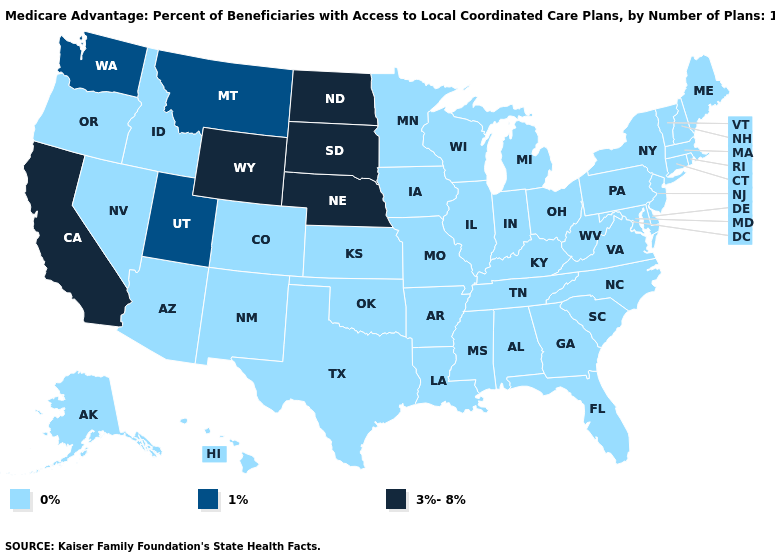What is the value of Ohio?
Concise answer only. 0%. Among the states that border Tennessee , which have the highest value?
Quick response, please. Georgia, Kentucky, Missouri, Mississippi, North Carolina, Virginia, Alabama, Arkansas. Which states have the lowest value in the USA?
Write a very short answer. Colorado, Connecticut, Delaware, Florida, Georgia, Hawaii, Iowa, Idaho, Illinois, Indiana, Kansas, Kentucky, Louisiana, Massachusetts, Maryland, Maine, Michigan, Minnesota, Missouri, Mississippi, North Carolina, New Hampshire, New Jersey, New Mexico, Nevada, New York, Ohio, Oklahoma, Oregon, Pennsylvania, Rhode Island, South Carolina, Alaska, Tennessee, Texas, Virginia, Vermont, Wisconsin, West Virginia, Alabama, Arkansas, Arizona. Which states have the highest value in the USA?
Be succinct. California, North Dakota, Nebraska, South Dakota, Wyoming. Name the states that have a value in the range 0%?
Quick response, please. Colorado, Connecticut, Delaware, Florida, Georgia, Hawaii, Iowa, Idaho, Illinois, Indiana, Kansas, Kentucky, Louisiana, Massachusetts, Maryland, Maine, Michigan, Minnesota, Missouri, Mississippi, North Carolina, New Hampshire, New Jersey, New Mexico, Nevada, New York, Ohio, Oklahoma, Oregon, Pennsylvania, Rhode Island, South Carolina, Alaska, Tennessee, Texas, Virginia, Vermont, Wisconsin, West Virginia, Alabama, Arkansas, Arizona. Among the states that border Minnesota , which have the lowest value?
Give a very brief answer. Iowa, Wisconsin. Which states have the highest value in the USA?
Short answer required. California, North Dakota, Nebraska, South Dakota, Wyoming. What is the value of Iowa?
Give a very brief answer. 0%. Name the states that have a value in the range 0%?
Write a very short answer. Colorado, Connecticut, Delaware, Florida, Georgia, Hawaii, Iowa, Idaho, Illinois, Indiana, Kansas, Kentucky, Louisiana, Massachusetts, Maryland, Maine, Michigan, Minnesota, Missouri, Mississippi, North Carolina, New Hampshire, New Jersey, New Mexico, Nevada, New York, Ohio, Oklahoma, Oregon, Pennsylvania, Rhode Island, South Carolina, Alaska, Tennessee, Texas, Virginia, Vermont, Wisconsin, West Virginia, Alabama, Arkansas, Arizona. Does the map have missing data?
Quick response, please. No. Is the legend a continuous bar?
Keep it brief. No. Does Kentucky have the same value as Ohio?
Give a very brief answer. Yes. Which states hav the highest value in the South?
Short answer required. Delaware, Florida, Georgia, Kentucky, Louisiana, Maryland, Mississippi, North Carolina, Oklahoma, South Carolina, Tennessee, Texas, Virginia, West Virginia, Alabama, Arkansas. What is the value of South Carolina?
Give a very brief answer. 0%. Which states have the lowest value in the Northeast?
Keep it brief. Connecticut, Massachusetts, Maine, New Hampshire, New Jersey, New York, Pennsylvania, Rhode Island, Vermont. 